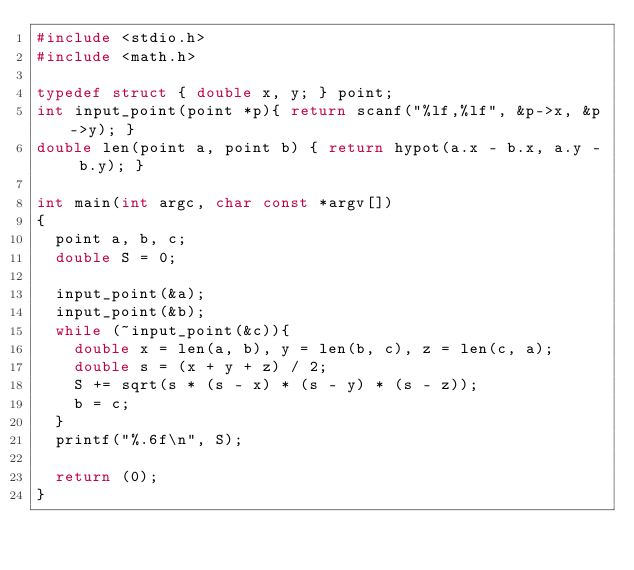<code> <loc_0><loc_0><loc_500><loc_500><_C_>#include <stdio.h>
#include <math.h>

typedef struct { double x, y; } point;
int input_point(point *p){ return scanf("%lf,%lf", &p->x, &p->y); }
double len(point a, point b) { return hypot(a.x - b.x, a.y - b.y); }

int main(int argc, char const *argv[])
{
	point a, b, c;
	double S = 0;

	input_point(&a);
	input_point(&b);
	while (~input_point(&c)){
		double x = len(a, b), y = len(b, c), z = len(c, a);
		double s = (x + y + z) / 2;
		S += sqrt(s * (s - x) * (s - y) * (s - z));
		b = c;
	}
	printf("%.6f\n", S);

	return (0);
}</code> 